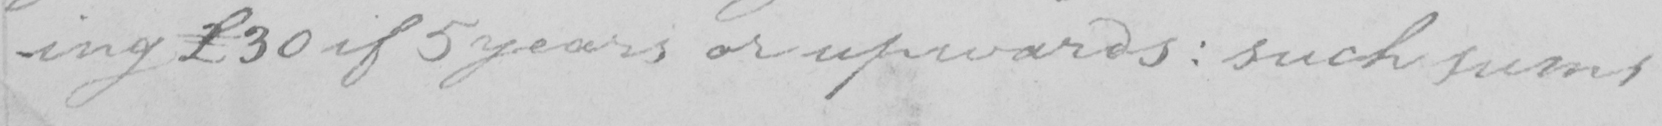What text is written in this handwritten line? -ing £30 if 5 years or upwards :  such sums 